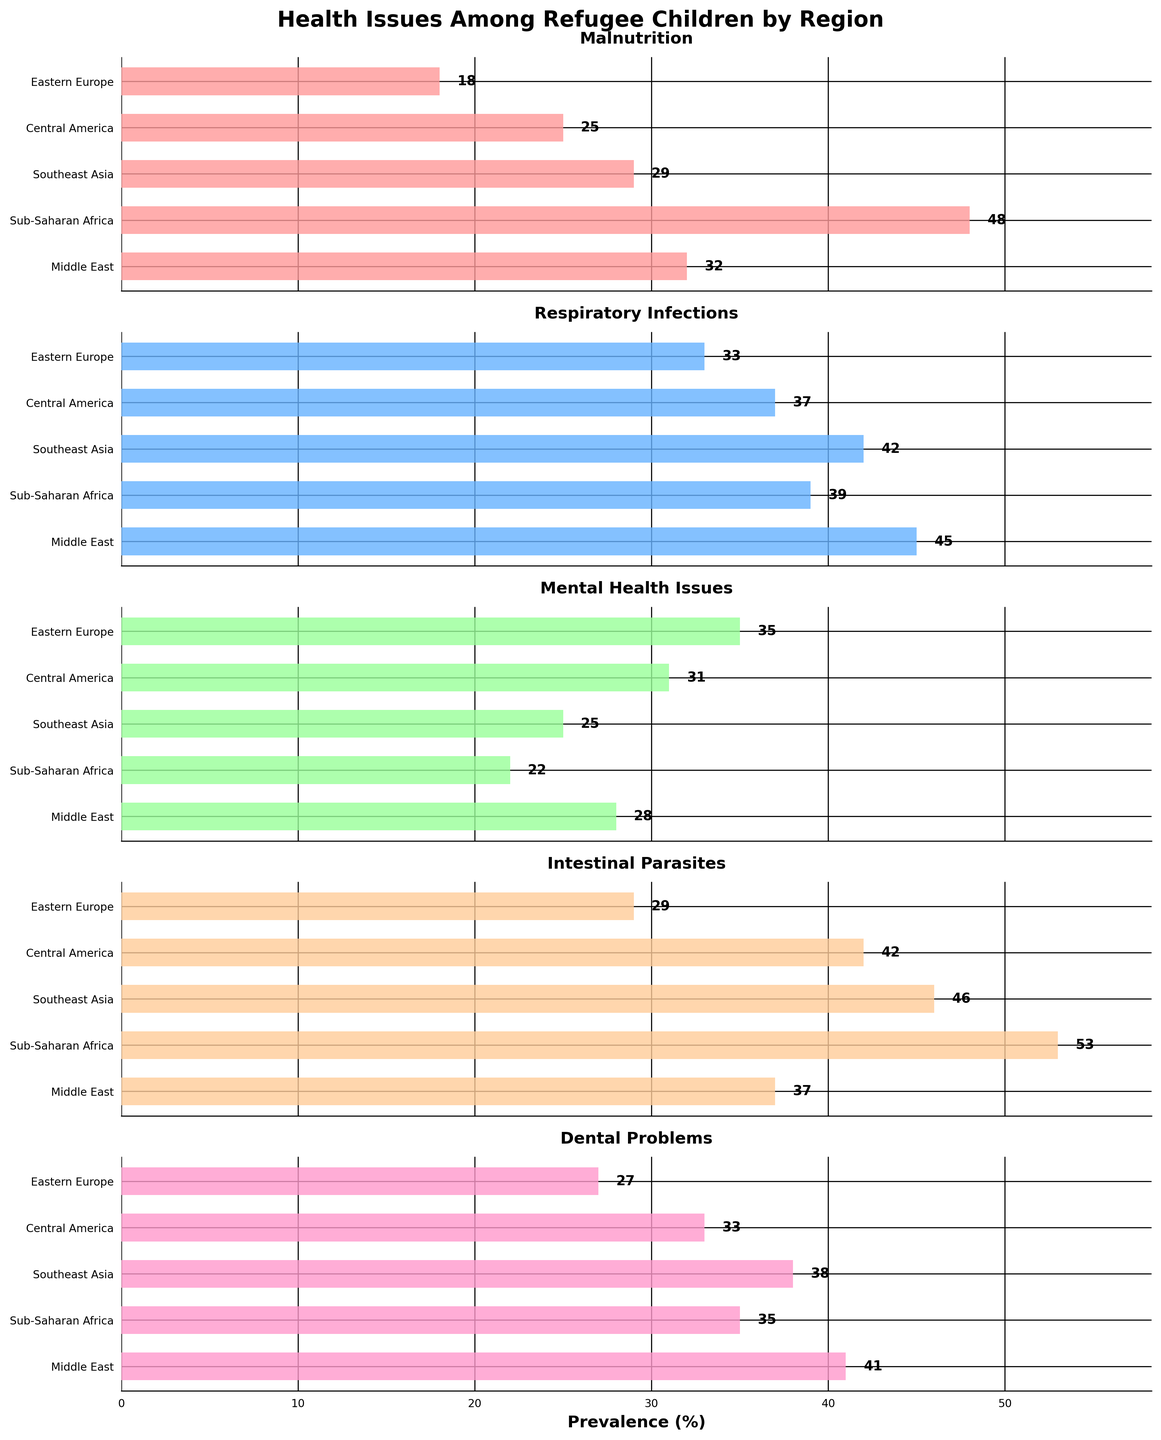How many regions are represented in the figure? By counting the number of horizontal bars in any of the subplots, we see there are five different regions.
Answer: Five Which health issue has the highest prevalence in Sub-Saharan Africa? For Sub-Saharan Africa, compare the height of the bars in each subplot. The highest bar represents Intestinal Parasites, with a prevalence of 53%.
Answer: Intestinal Parasites What is the total prevalence of Mental Health Issues across all regions? Add the prevalence percentages for Mental Health Issues from all regions: 28 (Middle East) + 22 (Sub-Saharan Africa) + 25 (Southeast Asia) + 31 (Central America) + 35 (Eastern Europe). The total is 141%.
Answer: 141% In which region is Malnutrition least prevalent? By comparing the bars for Malnutrition across all regions, the shortest bar is for Eastern Europe with a prevalence of 18%.
Answer: Eastern Europe Is the prevalence of Dental Problems higher in Southeast Asia or Central America? Compare the bars for Dental Problems in the Southeast Asia and Central America subplots. Southeast Asia has a prevalence of 38%, while Central America has 33%.
Answer: Southeast Asia Which region has the most diverse range of health issue prevalences? Determine the range for each region and compare them. The difference between the highest and lowest prevalence values is widest for Sub-Saharan Africa (53 - 22 = 31).
Answer: Sub-Saharan Africa What is the average prevalence of Respiratory Infections across all regions? Add the prevalence percentages for Respiratory Infections from all regions: 45 (Middle East) + 39 (Sub-Saharan Africa) + 42 (Southeast Asia) + 37 (Central America) + 33 (Eastern Europe). The total is 196%. Divide by 5 (the number of regions) to get the average. 196 / 5 = 39.2%.
Answer: 39.2% Across all regions, which health issue generally has the lowest prevalence? By visually inspecting the subplots, Mental Health Issues have the lowest prevalence in most regions compared to other issues.
Answer: Mental Health Issues 